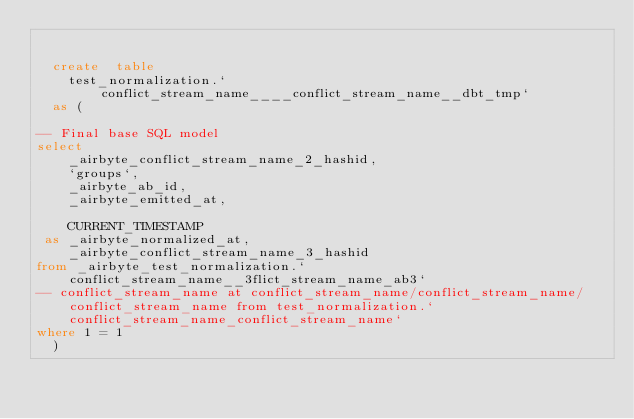Convert code to text. <code><loc_0><loc_0><loc_500><loc_500><_SQL_>

  create  table
    test_normalization.`conflict_stream_name____conflict_stream_name__dbt_tmp`
  as (
    
-- Final base SQL model
select
    _airbyte_conflict_stream_name_2_hashid,
    `groups`,
    _airbyte_ab_id,
    _airbyte_emitted_at,
    
    CURRENT_TIMESTAMP
 as _airbyte_normalized_at,
    _airbyte_conflict_stream_name_3_hashid
from _airbyte_test_normalization.`conflict_stream_name__3flict_stream_name_ab3`
-- conflict_stream_name at conflict_stream_name/conflict_stream_name/conflict_stream_name from test_normalization.`conflict_stream_name_conflict_stream_name`
where 1 = 1
  )
</code> 